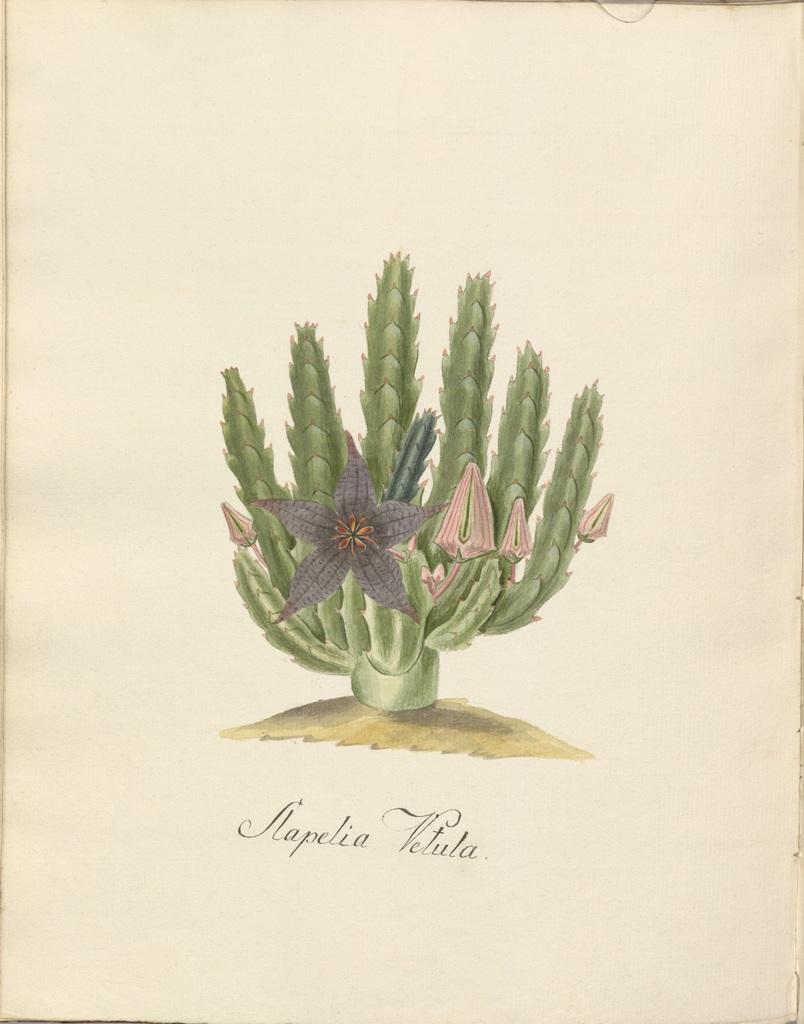How would you summarize this image in a sentence or two? In this image we can see a poster. On poster we can see a plant. There are many buds to a plant. There is a flower to a plant. There is some text at the bottom of the image. 